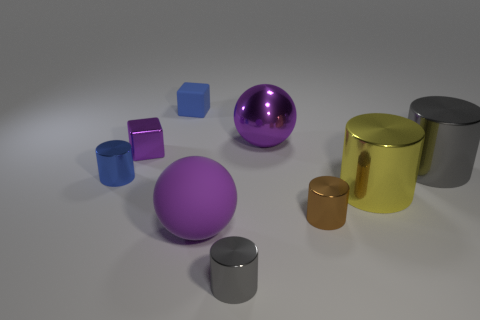What number of metal things are small gray spheres or big yellow things?
Provide a short and direct response. 1. Are there fewer purple cubes on the right side of the large yellow metal cylinder than brown rubber cylinders?
Offer a very short reply. No. The gray metallic object on the right side of the thing in front of the purple thing in front of the tiny blue metal cylinder is what shape?
Your answer should be compact. Cylinder. Is the color of the small rubber block the same as the metal cube?
Offer a terse response. No. Are there more small purple metal objects than big purple matte cubes?
Provide a succinct answer. Yes. What number of other objects are there of the same material as the brown thing?
Offer a terse response. 6. What number of things are either gray shiny cylinders or tiny cylinders to the right of the metal cube?
Your answer should be very brief. 3. Are there fewer large yellow things than tiny red cylinders?
Offer a very short reply. No. There is a large cylinder that is behind the tiny blue thing that is left of the cube that is on the left side of the tiny rubber object; what is its color?
Give a very brief answer. Gray. Does the small purple object have the same material as the tiny blue cylinder?
Your answer should be compact. Yes. 